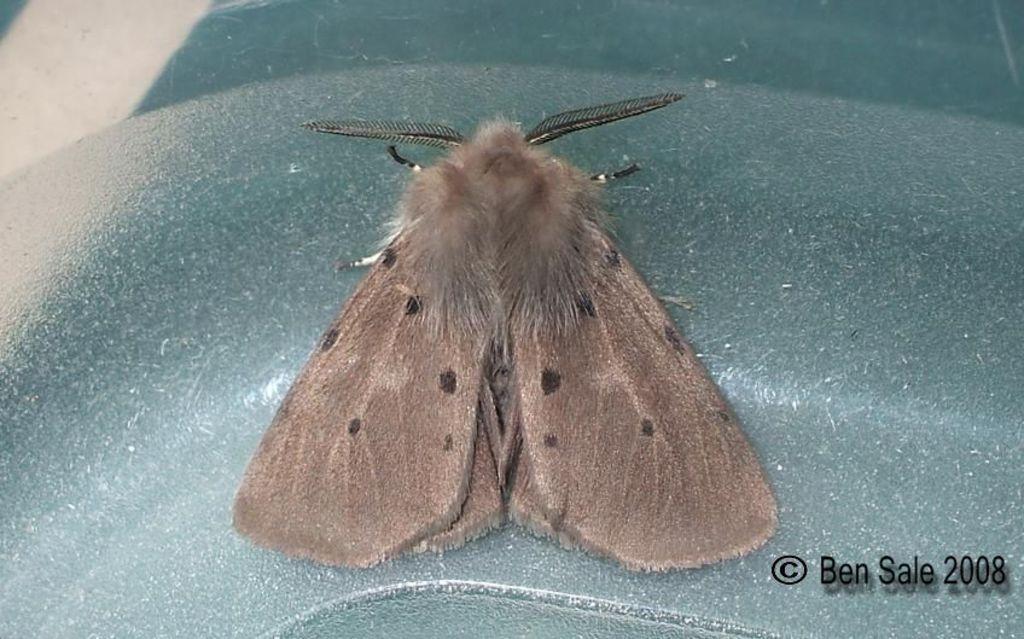In one or two sentences, can you explain what this image depicts? In this picture there is a brown color butterfly sitting on the blue color iron box. On the bottom side of the image there is a small quote and date is written. 